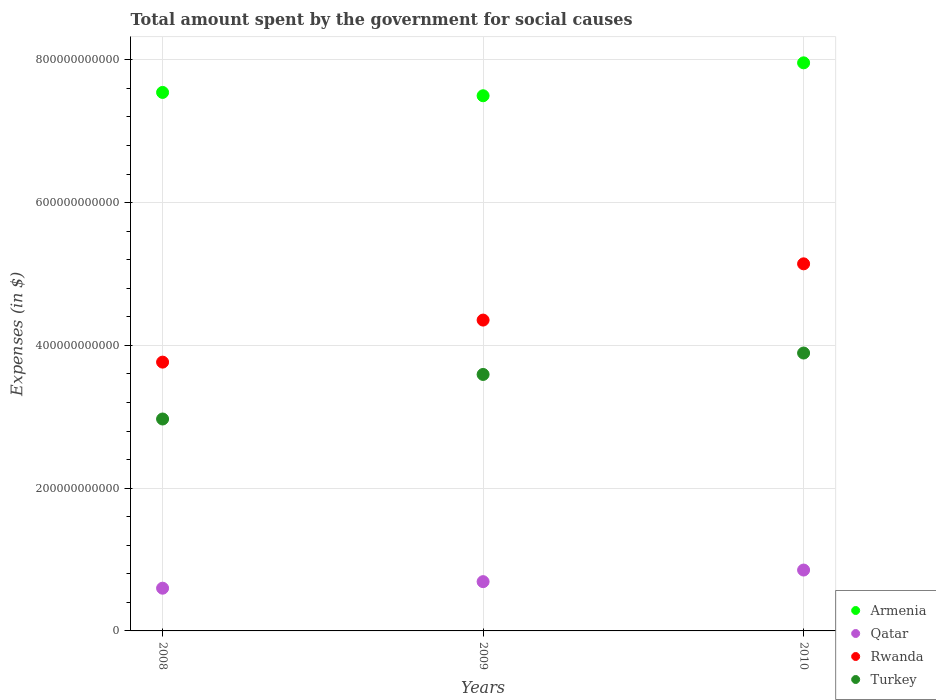How many different coloured dotlines are there?
Provide a succinct answer. 4. What is the amount spent for social causes by the government in Turkey in 2009?
Provide a short and direct response. 3.59e+11. Across all years, what is the maximum amount spent for social causes by the government in Armenia?
Make the answer very short. 7.96e+11. Across all years, what is the minimum amount spent for social causes by the government in Rwanda?
Provide a succinct answer. 3.77e+11. In which year was the amount spent for social causes by the government in Qatar maximum?
Keep it short and to the point. 2010. What is the total amount spent for social causes by the government in Armenia in the graph?
Ensure brevity in your answer.  2.30e+12. What is the difference between the amount spent for social causes by the government in Turkey in 2008 and that in 2009?
Offer a very short reply. -6.24e+1. What is the difference between the amount spent for social causes by the government in Qatar in 2009 and the amount spent for social causes by the government in Turkey in 2008?
Your answer should be very brief. -2.28e+11. What is the average amount spent for social causes by the government in Qatar per year?
Provide a succinct answer. 7.14e+1. In the year 2009, what is the difference between the amount spent for social causes by the government in Qatar and amount spent for social causes by the government in Armenia?
Make the answer very short. -6.81e+11. In how many years, is the amount spent for social causes by the government in Armenia greater than 240000000000 $?
Provide a short and direct response. 3. What is the ratio of the amount spent for social causes by the government in Armenia in 2009 to that in 2010?
Offer a terse response. 0.94. Is the amount spent for social causes by the government in Armenia in 2008 less than that in 2009?
Offer a terse response. No. What is the difference between the highest and the second highest amount spent for social causes by the government in Armenia?
Make the answer very short. 4.14e+1. What is the difference between the highest and the lowest amount spent for social causes by the government in Rwanda?
Offer a terse response. 1.38e+11. Is it the case that in every year, the sum of the amount spent for social causes by the government in Qatar and amount spent for social causes by the government in Armenia  is greater than the sum of amount spent for social causes by the government in Rwanda and amount spent for social causes by the government in Turkey?
Ensure brevity in your answer.  No. Does the amount spent for social causes by the government in Qatar monotonically increase over the years?
Ensure brevity in your answer.  Yes. Is the amount spent for social causes by the government in Rwanda strictly greater than the amount spent for social causes by the government in Turkey over the years?
Your answer should be compact. Yes. How many years are there in the graph?
Provide a short and direct response. 3. What is the difference between two consecutive major ticks on the Y-axis?
Provide a succinct answer. 2.00e+11. Does the graph contain any zero values?
Provide a succinct answer. No. How many legend labels are there?
Your response must be concise. 4. How are the legend labels stacked?
Provide a short and direct response. Vertical. What is the title of the graph?
Make the answer very short. Total amount spent by the government for social causes. What is the label or title of the Y-axis?
Make the answer very short. Expenses (in $). What is the Expenses (in $) in Armenia in 2008?
Offer a terse response. 7.54e+11. What is the Expenses (in $) in Qatar in 2008?
Offer a terse response. 5.98e+1. What is the Expenses (in $) of Rwanda in 2008?
Your response must be concise. 3.77e+11. What is the Expenses (in $) of Turkey in 2008?
Your answer should be very brief. 2.97e+11. What is the Expenses (in $) in Armenia in 2009?
Make the answer very short. 7.50e+11. What is the Expenses (in $) in Qatar in 2009?
Offer a very short reply. 6.90e+1. What is the Expenses (in $) in Rwanda in 2009?
Provide a succinct answer. 4.35e+11. What is the Expenses (in $) in Turkey in 2009?
Provide a short and direct response. 3.59e+11. What is the Expenses (in $) in Armenia in 2010?
Keep it short and to the point. 7.96e+11. What is the Expenses (in $) in Qatar in 2010?
Offer a very short reply. 8.53e+1. What is the Expenses (in $) in Rwanda in 2010?
Ensure brevity in your answer.  5.14e+11. What is the Expenses (in $) of Turkey in 2010?
Keep it short and to the point. 3.89e+11. Across all years, what is the maximum Expenses (in $) of Armenia?
Ensure brevity in your answer.  7.96e+11. Across all years, what is the maximum Expenses (in $) in Qatar?
Provide a short and direct response. 8.53e+1. Across all years, what is the maximum Expenses (in $) of Rwanda?
Offer a terse response. 5.14e+11. Across all years, what is the maximum Expenses (in $) of Turkey?
Give a very brief answer. 3.89e+11. Across all years, what is the minimum Expenses (in $) of Armenia?
Provide a succinct answer. 7.50e+11. Across all years, what is the minimum Expenses (in $) of Qatar?
Your answer should be very brief. 5.98e+1. Across all years, what is the minimum Expenses (in $) of Rwanda?
Your answer should be compact. 3.77e+11. Across all years, what is the minimum Expenses (in $) in Turkey?
Give a very brief answer. 2.97e+11. What is the total Expenses (in $) in Armenia in the graph?
Provide a succinct answer. 2.30e+12. What is the total Expenses (in $) in Qatar in the graph?
Ensure brevity in your answer.  2.14e+11. What is the total Expenses (in $) in Rwanda in the graph?
Offer a very short reply. 1.33e+12. What is the total Expenses (in $) of Turkey in the graph?
Offer a very short reply. 1.05e+12. What is the difference between the Expenses (in $) in Armenia in 2008 and that in 2009?
Provide a short and direct response. 4.65e+09. What is the difference between the Expenses (in $) in Qatar in 2008 and that in 2009?
Offer a very short reply. -9.17e+09. What is the difference between the Expenses (in $) of Rwanda in 2008 and that in 2009?
Keep it short and to the point. -5.89e+1. What is the difference between the Expenses (in $) of Turkey in 2008 and that in 2009?
Provide a succinct answer. -6.24e+1. What is the difference between the Expenses (in $) in Armenia in 2008 and that in 2010?
Provide a short and direct response. -4.14e+1. What is the difference between the Expenses (in $) in Qatar in 2008 and that in 2010?
Your response must be concise. -2.54e+1. What is the difference between the Expenses (in $) of Rwanda in 2008 and that in 2010?
Your answer should be very brief. -1.38e+11. What is the difference between the Expenses (in $) of Turkey in 2008 and that in 2010?
Your response must be concise. -9.24e+1. What is the difference between the Expenses (in $) in Armenia in 2009 and that in 2010?
Your response must be concise. -4.61e+1. What is the difference between the Expenses (in $) in Qatar in 2009 and that in 2010?
Provide a short and direct response. -1.63e+1. What is the difference between the Expenses (in $) in Rwanda in 2009 and that in 2010?
Your answer should be very brief. -7.88e+1. What is the difference between the Expenses (in $) in Turkey in 2009 and that in 2010?
Your answer should be very brief. -3.00e+1. What is the difference between the Expenses (in $) of Armenia in 2008 and the Expenses (in $) of Qatar in 2009?
Provide a succinct answer. 6.85e+11. What is the difference between the Expenses (in $) in Armenia in 2008 and the Expenses (in $) in Rwanda in 2009?
Your answer should be compact. 3.19e+11. What is the difference between the Expenses (in $) in Armenia in 2008 and the Expenses (in $) in Turkey in 2009?
Your answer should be compact. 3.95e+11. What is the difference between the Expenses (in $) in Qatar in 2008 and the Expenses (in $) in Rwanda in 2009?
Provide a succinct answer. -3.76e+11. What is the difference between the Expenses (in $) in Qatar in 2008 and the Expenses (in $) in Turkey in 2009?
Make the answer very short. -2.99e+11. What is the difference between the Expenses (in $) in Rwanda in 2008 and the Expenses (in $) in Turkey in 2009?
Offer a terse response. 1.73e+1. What is the difference between the Expenses (in $) of Armenia in 2008 and the Expenses (in $) of Qatar in 2010?
Make the answer very short. 6.69e+11. What is the difference between the Expenses (in $) in Armenia in 2008 and the Expenses (in $) in Rwanda in 2010?
Offer a very short reply. 2.40e+11. What is the difference between the Expenses (in $) in Armenia in 2008 and the Expenses (in $) in Turkey in 2010?
Keep it short and to the point. 3.65e+11. What is the difference between the Expenses (in $) of Qatar in 2008 and the Expenses (in $) of Rwanda in 2010?
Give a very brief answer. -4.54e+11. What is the difference between the Expenses (in $) in Qatar in 2008 and the Expenses (in $) in Turkey in 2010?
Ensure brevity in your answer.  -3.29e+11. What is the difference between the Expenses (in $) in Rwanda in 2008 and the Expenses (in $) in Turkey in 2010?
Keep it short and to the point. -1.27e+1. What is the difference between the Expenses (in $) in Armenia in 2009 and the Expenses (in $) in Qatar in 2010?
Your answer should be very brief. 6.64e+11. What is the difference between the Expenses (in $) of Armenia in 2009 and the Expenses (in $) of Rwanda in 2010?
Ensure brevity in your answer.  2.35e+11. What is the difference between the Expenses (in $) in Armenia in 2009 and the Expenses (in $) in Turkey in 2010?
Give a very brief answer. 3.60e+11. What is the difference between the Expenses (in $) in Qatar in 2009 and the Expenses (in $) in Rwanda in 2010?
Offer a very short reply. -4.45e+11. What is the difference between the Expenses (in $) of Qatar in 2009 and the Expenses (in $) of Turkey in 2010?
Offer a very short reply. -3.20e+11. What is the difference between the Expenses (in $) in Rwanda in 2009 and the Expenses (in $) in Turkey in 2010?
Your answer should be very brief. 4.62e+1. What is the average Expenses (in $) of Armenia per year?
Give a very brief answer. 7.67e+11. What is the average Expenses (in $) in Qatar per year?
Give a very brief answer. 7.14e+1. What is the average Expenses (in $) in Rwanda per year?
Provide a succinct answer. 4.42e+11. What is the average Expenses (in $) in Turkey per year?
Give a very brief answer. 3.48e+11. In the year 2008, what is the difference between the Expenses (in $) in Armenia and Expenses (in $) in Qatar?
Give a very brief answer. 6.94e+11. In the year 2008, what is the difference between the Expenses (in $) in Armenia and Expenses (in $) in Rwanda?
Keep it short and to the point. 3.78e+11. In the year 2008, what is the difference between the Expenses (in $) of Armenia and Expenses (in $) of Turkey?
Give a very brief answer. 4.57e+11. In the year 2008, what is the difference between the Expenses (in $) of Qatar and Expenses (in $) of Rwanda?
Ensure brevity in your answer.  -3.17e+11. In the year 2008, what is the difference between the Expenses (in $) of Qatar and Expenses (in $) of Turkey?
Give a very brief answer. -2.37e+11. In the year 2008, what is the difference between the Expenses (in $) in Rwanda and Expenses (in $) in Turkey?
Offer a terse response. 7.97e+1. In the year 2009, what is the difference between the Expenses (in $) of Armenia and Expenses (in $) of Qatar?
Offer a terse response. 6.81e+11. In the year 2009, what is the difference between the Expenses (in $) of Armenia and Expenses (in $) of Rwanda?
Provide a short and direct response. 3.14e+11. In the year 2009, what is the difference between the Expenses (in $) in Armenia and Expenses (in $) in Turkey?
Provide a short and direct response. 3.90e+11. In the year 2009, what is the difference between the Expenses (in $) in Qatar and Expenses (in $) in Rwanda?
Provide a short and direct response. -3.66e+11. In the year 2009, what is the difference between the Expenses (in $) of Qatar and Expenses (in $) of Turkey?
Ensure brevity in your answer.  -2.90e+11. In the year 2009, what is the difference between the Expenses (in $) of Rwanda and Expenses (in $) of Turkey?
Your answer should be very brief. 7.62e+1. In the year 2010, what is the difference between the Expenses (in $) in Armenia and Expenses (in $) in Qatar?
Offer a very short reply. 7.10e+11. In the year 2010, what is the difference between the Expenses (in $) of Armenia and Expenses (in $) of Rwanda?
Your answer should be very brief. 2.82e+11. In the year 2010, what is the difference between the Expenses (in $) in Armenia and Expenses (in $) in Turkey?
Provide a succinct answer. 4.07e+11. In the year 2010, what is the difference between the Expenses (in $) of Qatar and Expenses (in $) of Rwanda?
Your answer should be very brief. -4.29e+11. In the year 2010, what is the difference between the Expenses (in $) in Qatar and Expenses (in $) in Turkey?
Provide a succinct answer. -3.04e+11. In the year 2010, what is the difference between the Expenses (in $) in Rwanda and Expenses (in $) in Turkey?
Your answer should be very brief. 1.25e+11. What is the ratio of the Expenses (in $) of Armenia in 2008 to that in 2009?
Your answer should be compact. 1.01. What is the ratio of the Expenses (in $) of Qatar in 2008 to that in 2009?
Your response must be concise. 0.87. What is the ratio of the Expenses (in $) of Rwanda in 2008 to that in 2009?
Your response must be concise. 0.86. What is the ratio of the Expenses (in $) in Turkey in 2008 to that in 2009?
Provide a short and direct response. 0.83. What is the ratio of the Expenses (in $) in Armenia in 2008 to that in 2010?
Your answer should be very brief. 0.95. What is the ratio of the Expenses (in $) of Qatar in 2008 to that in 2010?
Your answer should be very brief. 0.7. What is the ratio of the Expenses (in $) in Rwanda in 2008 to that in 2010?
Keep it short and to the point. 0.73. What is the ratio of the Expenses (in $) of Turkey in 2008 to that in 2010?
Keep it short and to the point. 0.76. What is the ratio of the Expenses (in $) of Armenia in 2009 to that in 2010?
Give a very brief answer. 0.94. What is the ratio of the Expenses (in $) in Qatar in 2009 to that in 2010?
Keep it short and to the point. 0.81. What is the ratio of the Expenses (in $) in Rwanda in 2009 to that in 2010?
Provide a short and direct response. 0.85. What is the ratio of the Expenses (in $) in Turkey in 2009 to that in 2010?
Offer a very short reply. 0.92. What is the difference between the highest and the second highest Expenses (in $) of Armenia?
Offer a very short reply. 4.14e+1. What is the difference between the highest and the second highest Expenses (in $) of Qatar?
Keep it short and to the point. 1.63e+1. What is the difference between the highest and the second highest Expenses (in $) of Rwanda?
Give a very brief answer. 7.88e+1. What is the difference between the highest and the second highest Expenses (in $) in Turkey?
Ensure brevity in your answer.  3.00e+1. What is the difference between the highest and the lowest Expenses (in $) of Armenia?
Offer a terse response. 4.61e+1. What is the difference between the highest and the lowest Expenses (in $) of Qatar?
Keep it short and to the point. 2.54e+1. What is the difference between the highest and the lowest Expenses (in $) in Rwanda?
Give a very brief answer. 1.38e+11. What is the difference between the highest and the lowest Expenses (in $) in Turkey?
Make the answer very short. 9.24e+1. 